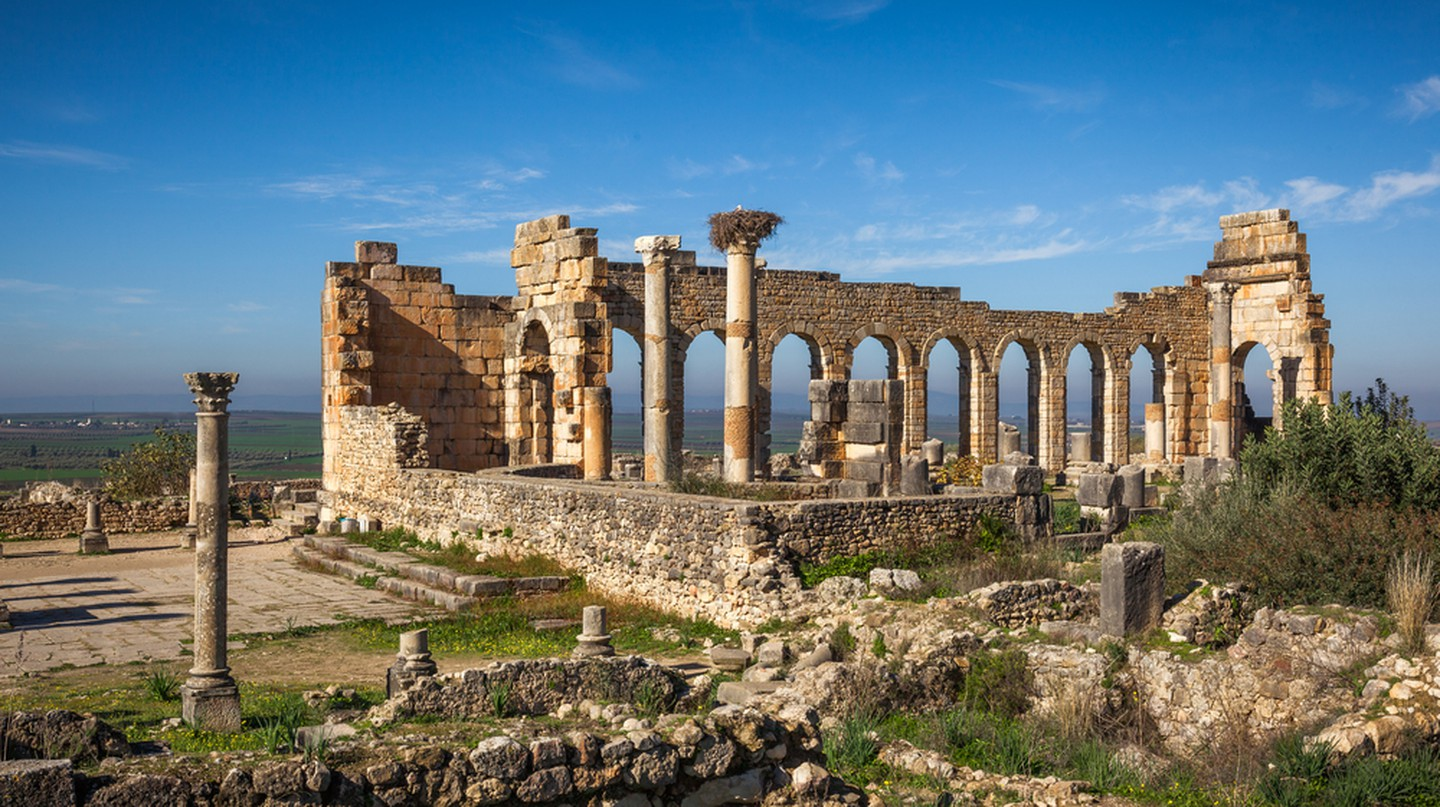Describe the following image. The image captures the ancient Roman ruins of Volubilis in Morocco, a testament to the grandeur of past civilizations. The ruins, constructed of stone, stand in various states of decay, yet retain a sense of their original majesty. The remnants of arches, columns, and walls hint at the architectural prowess of the Romans. The perspective of the photo is from the ground, looking up at the ruins, giving a sense of their imposing stature. The ruins are set against a backdrop of a clear blue sky and verdant green fields, a stark contrast to the weathered stone of the ruins. The distance from which the photo is taken allows for a comprehensive view of the landmark, placing it within the context of its natural surroundings. The image is a blend of history and nature, a snapshot of a moment where the past meets the present. 